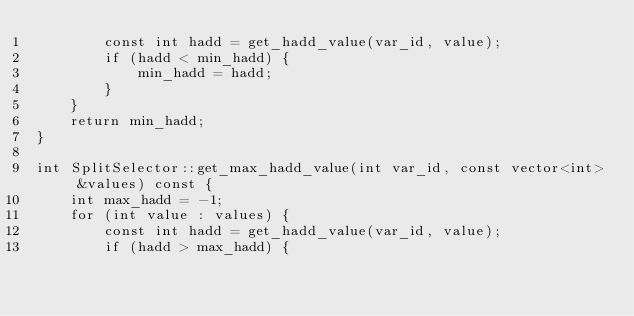Convert code to text. <code><loc_0><loc_0><loc_500><loc_500><_C++_>        const int hadd = get_hadd_value(var_id, value);
        if (hadd < min_hadd) {
            min_hadd = hadd;
        }
    }
    return min_hadd;
}

int SplitSelector::get_max_hadd_value(int var_id, const vector<int> &values) const {
    int max_hadd = -1;
    for (int value : values) {
        const int hadd = get_hadd_value(var_id, value);
        if (hadd > max_hadd) {</code> 